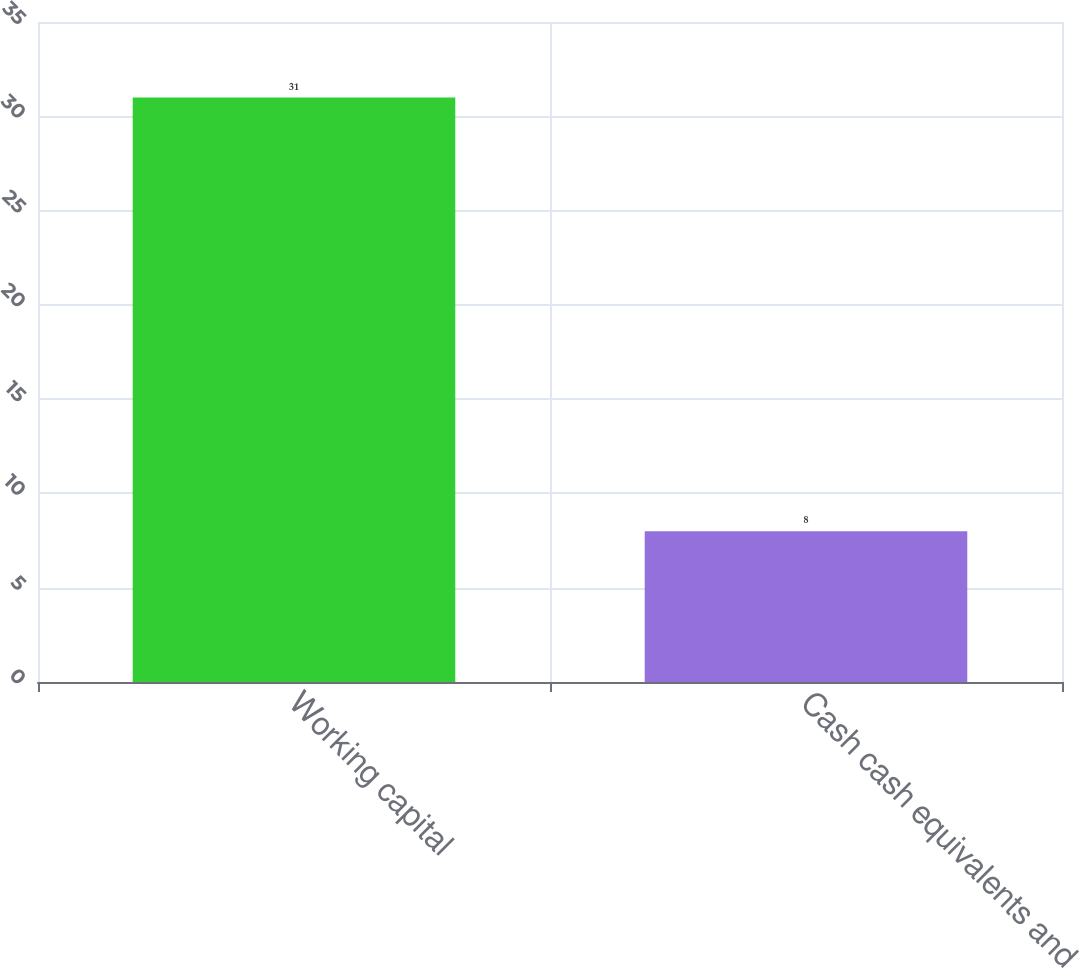Convert chart to OTSL. <chart><loc_0><loc_0><loc_500><loc_500><bar_chart><fcel>Working capital<fcel>Cash cash equivalents and<nl><fcel>31<fcel>8<nl></chart> 